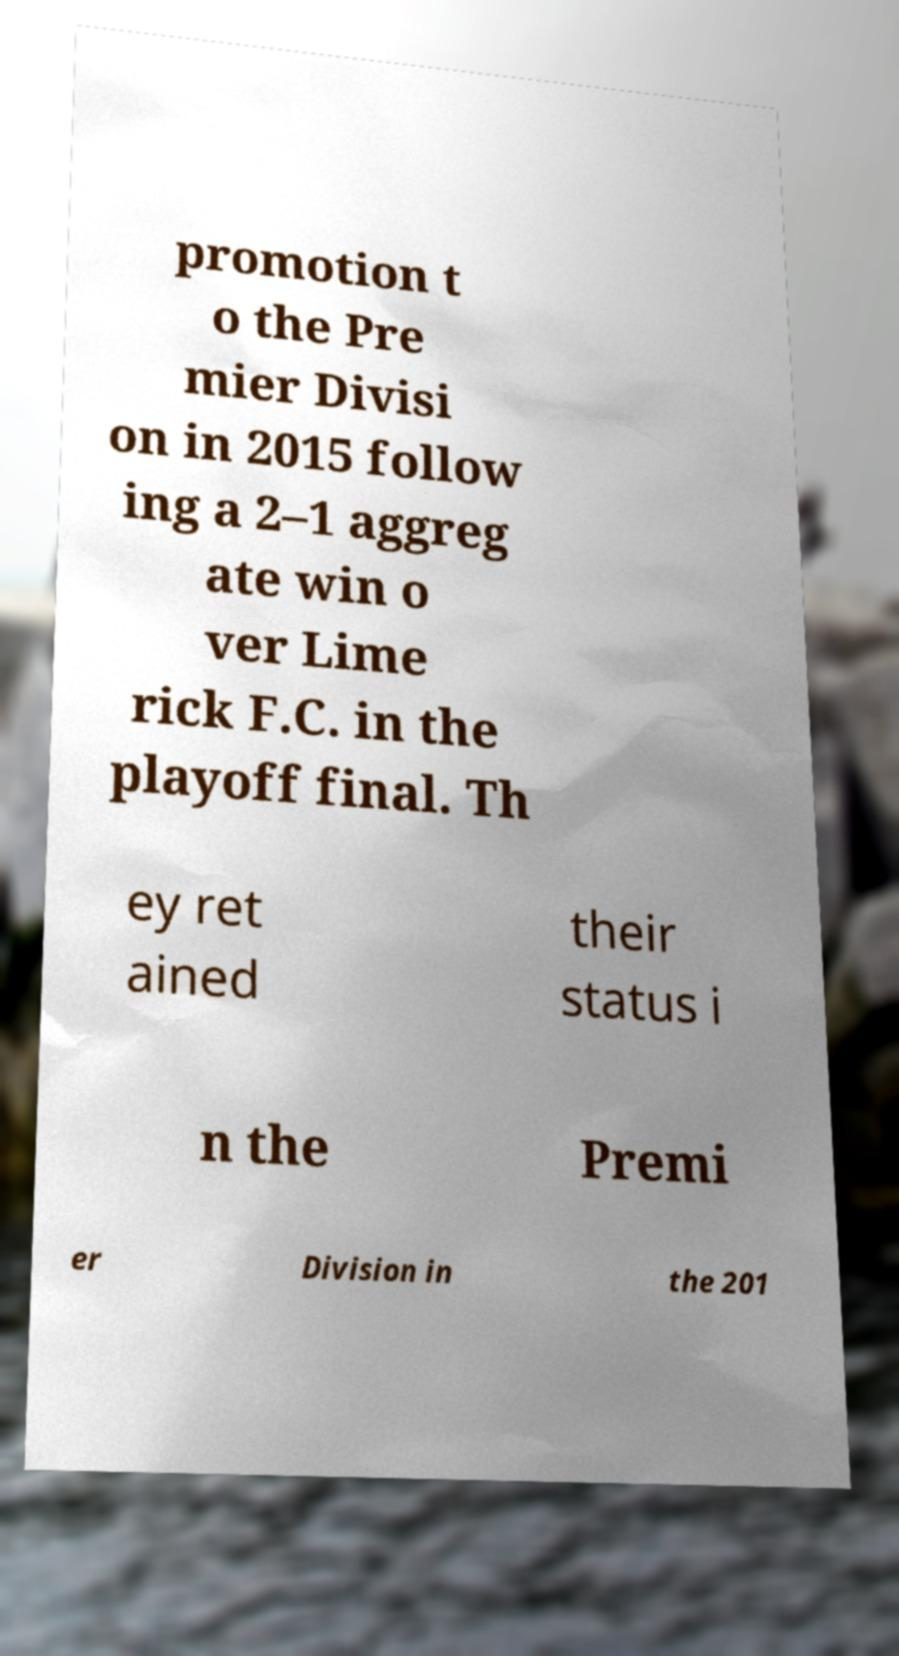Could you extract and type out the text from this image? promotion t o the Pre mier Divisi on in 2015 follow ing a 2–1 aggreg ate win o ver Lime rick F.C. in the playoff final. Th ey ret ained their status i n the Premi er Division in the 201 